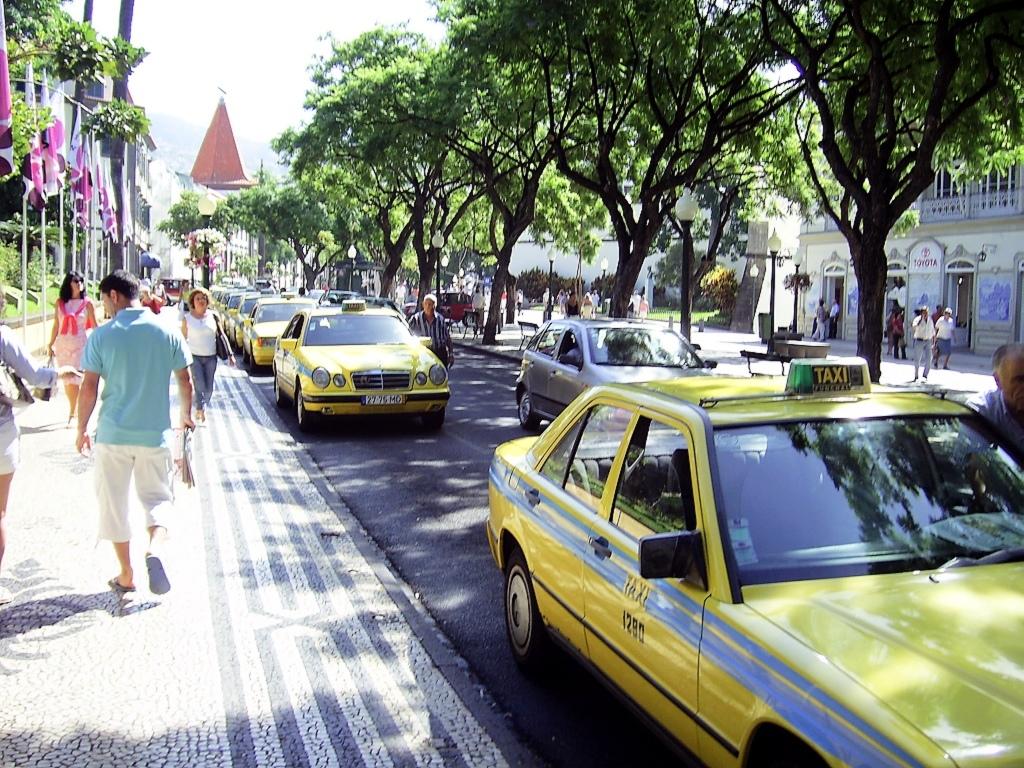What kind of car are these yellow cars?
Give a very brief answer. Taxi. 